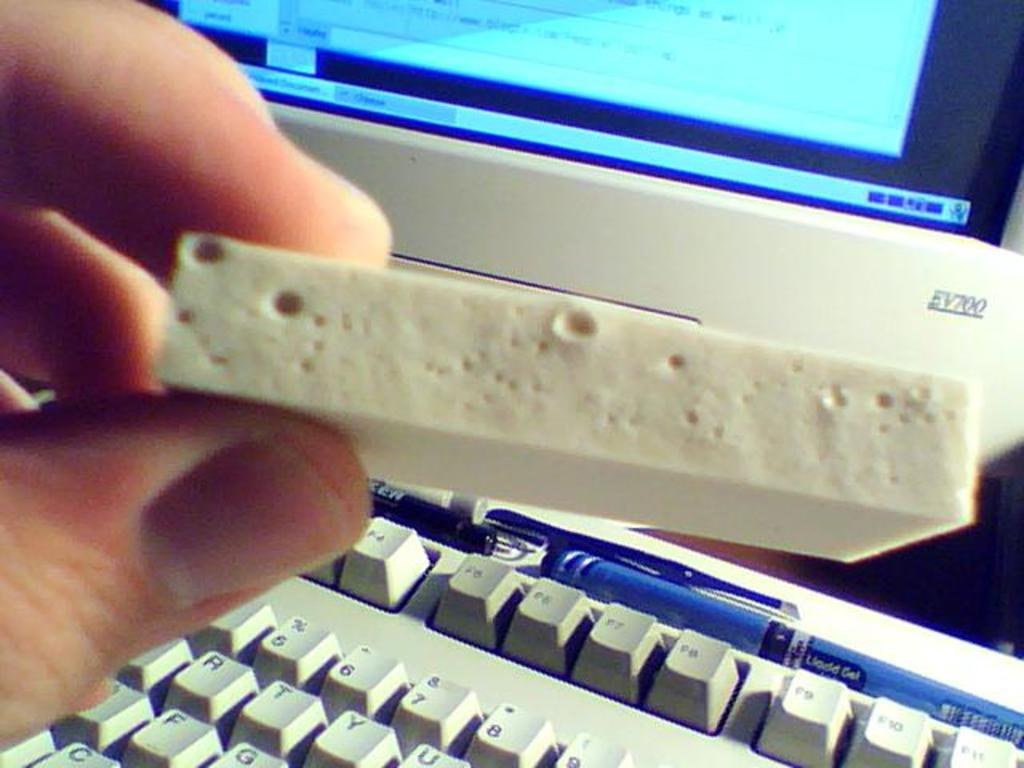<image>
Describe the image concisely. A strange object is held above the Function keys of a keyboard. 